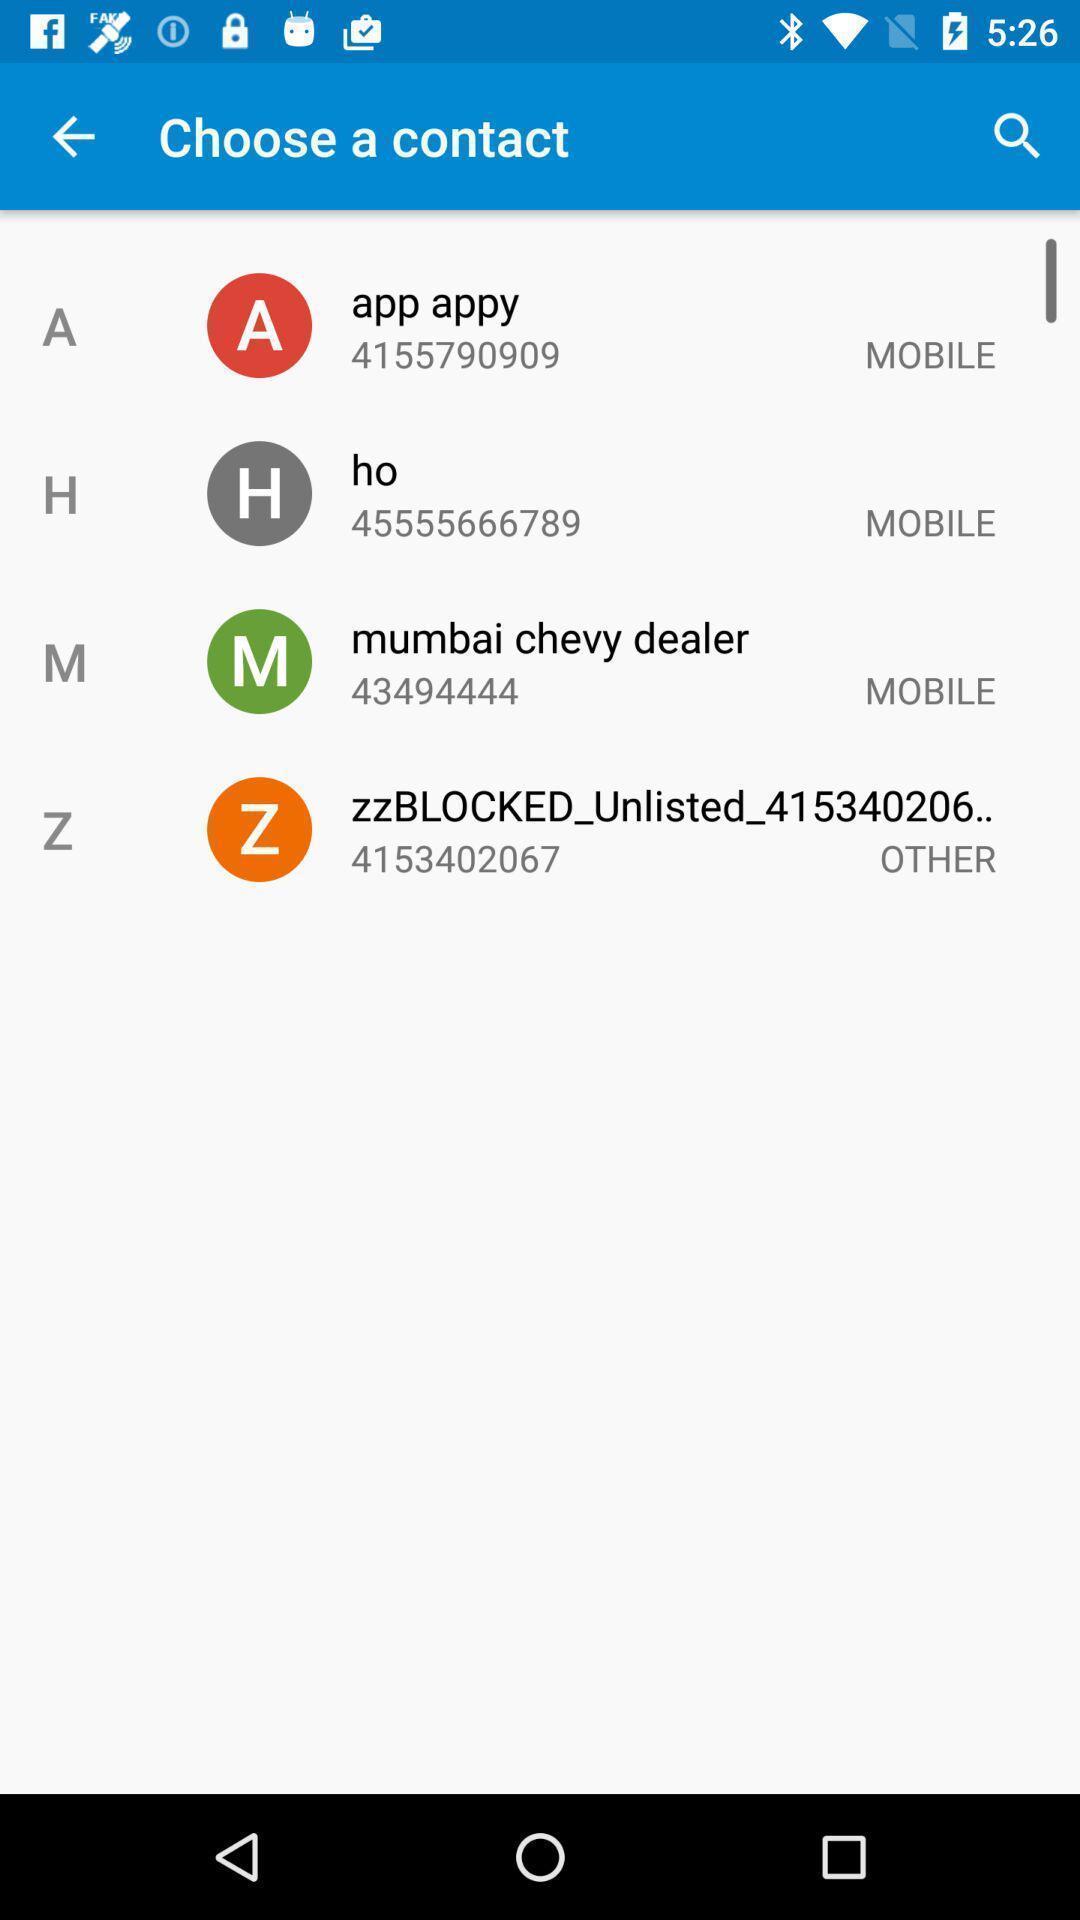Provide a detailed account of this screenshot. Screen page of a list of contacts. 